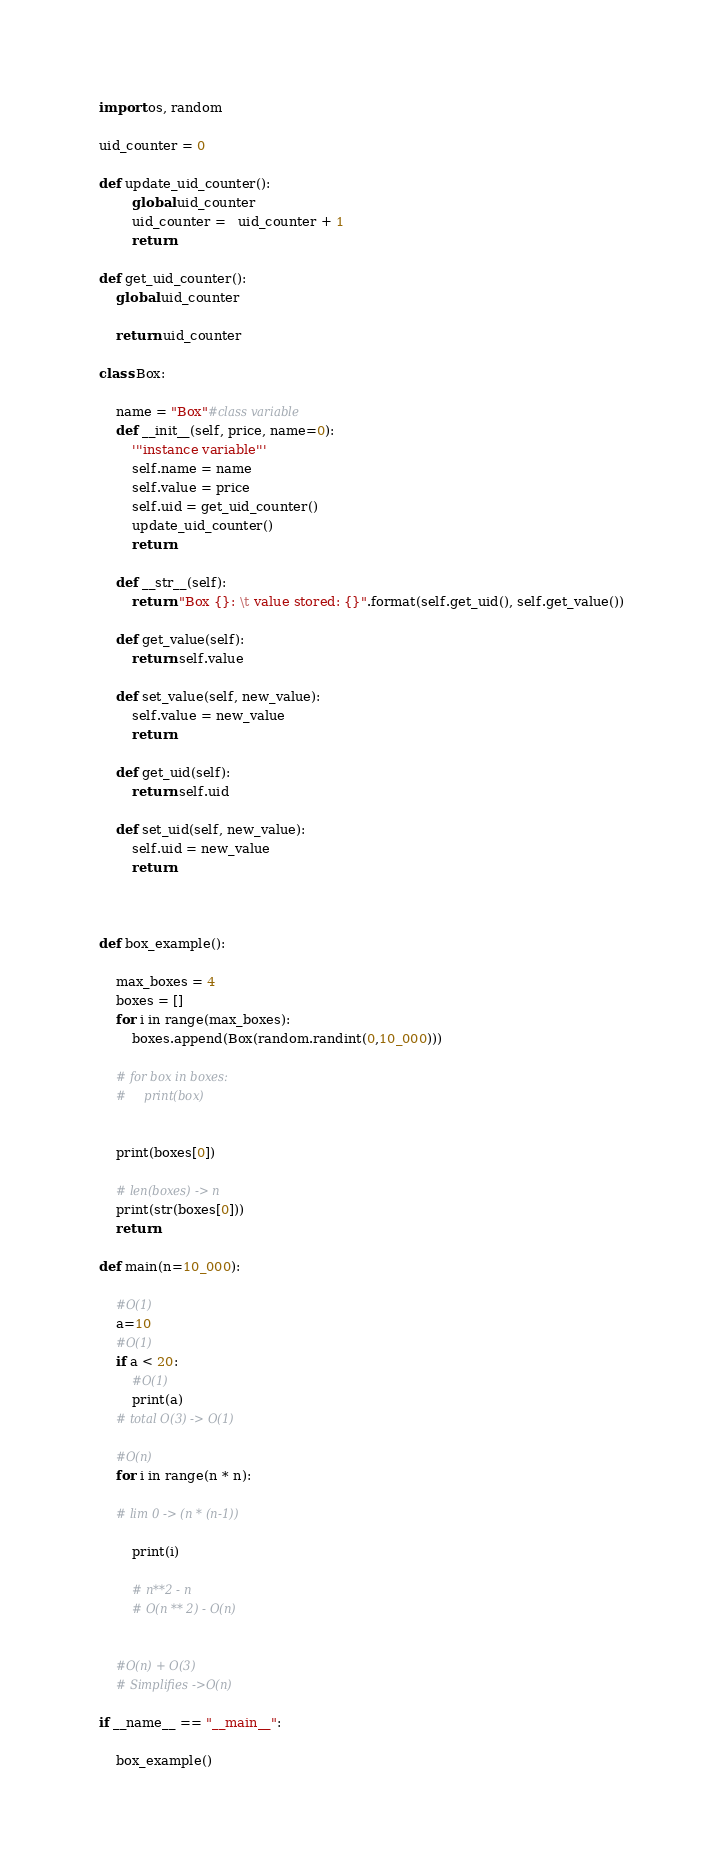<code> <loc_0><loc_0><loc_500><loc_500><_Python_>import os, random

uid_counter = 0

def update_uid_counter():
        global uid_counter
        uid_counter =   uid_counter + 1
        return

def get_uid_counter():
    global uid_counter

    return uid_counter

class Box:
    
    name = "Box"#class variable
    def __init__(self, price, name=0):
        '''instance variable'''
        self.name = name
        self.value = price
        self.uid = get_uid_counter()
        update_uid_counter()
        return

    def __str__(self):
        return "Box {}: \t value stored: {}".format(self.get_uid(), self.get_value())
    
    def get_value(self):
        return self.value

    def set_value(self, new_value):
        self.value = new_value
        return
    
    def get_uid(self):
        return self.uid

    def set_uid(self, new_value):
        self.uid = new_value
        return 
    
    

def box_example():

    max_boxes = 4
    boxes = []
    for i in range(max_boxes):
        boxes.append(Box(random.randint(0,10_000)))

    # for box in boxes:
    #     print(box)
    

    print(boxes[0])

    # len(boxes) -> n
    print(str(boxes[0]))
    return

def main(n=10_000):

    #O(1)
    a=10
    #O(1)
    if a < 20:
        #O(1)
        print(a)
    # total O(3) -> O(1)
    
    #O(n)
    for i in range(n * n):

    # lim 0 -> (n * (n-1))

        print(i)

        # n**2 - n 
        # O(n ** 2) - O(n)


    #O(n) + O(3)
    # Simplifies ->O(n)

if __name__ == "__main__":

    box_example()</code> 